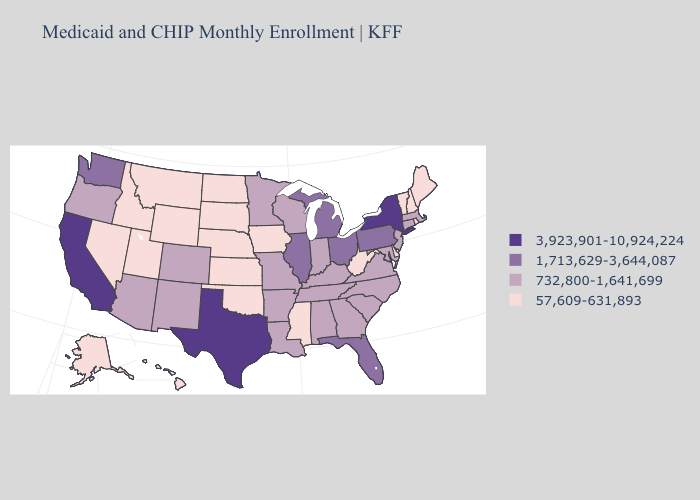Does Nevada have the same value as Connecticut?
Write a very short answer. No. Among the states that border Tennessee , does Virginia have the lowest value?
Answer briefly. No. Does Oregon have a higher value than New Jersey?
Answer briefly. No. How many symbols are there in the legend?
Keep it brief. 4. What is the value of New York?
Keep it brief. 3,923,901-10,924,224. Name the states that have a value in the range 732,800-1,641,699?
Concise answer only. Alabama, Arizona, Arkansas, Colorado, Connecticut, Georgia, Indiana, Kentucky, Louisiana, Maryland, Massachusetts, Minnesota, Missouri, New Jersey, New Mexico, North Carolina, Oregon, South Carolina, Tennessee, Virginia, Wisconsin. Name the states that have a value in the range 1,713,629-3,644,087?
Write a very short answer. Florida, Illinois, Michigan, Ohio, Pennsylvania, Washington. Name the states that have a value in the range 732,800-1,641,699?
Quick response, please. Alabama, Arizona, Arkansas, Colorado, Connecticut, Georgia, Indiana, Kentucky, Louisiana, Maryland, Massachusetts, Minnesota, Missouri, New Jersey, New Mexico, North Carolina, Oregon, South Carolina, Tennessee, Virginia, Wisconsin. What is the highest value in the USA?
Quick response, please. 3,923,901-10,924,224. Name the states that have a value in the range 57,609-631,893?
Short answer required. Alaska, Delaware, Hawaii, Idaho, Iowa, Kansas, Maine, Mississippi, Montana, Nebraska, Nevada, New Hampshire, North Dakota, Oklahoma, Rhode Island, South Dakota, Utah, Vermont, West Virginia, Wyoming. Does California have the highest value in the USA?
Short answer required. Yes. Among the states that border North Carolina , which have the lowest value?
Short answer required. Georgia, South Carolina, Tennessee, Virginia. Does Nebraska have a lower value than Kentucky?
Give a very brief answer. Yes. What is the value of California?
Short answer required. 3,923,901-10,924,224. Does California have the lowest value in the USA?
Give a very brief answer. No. 